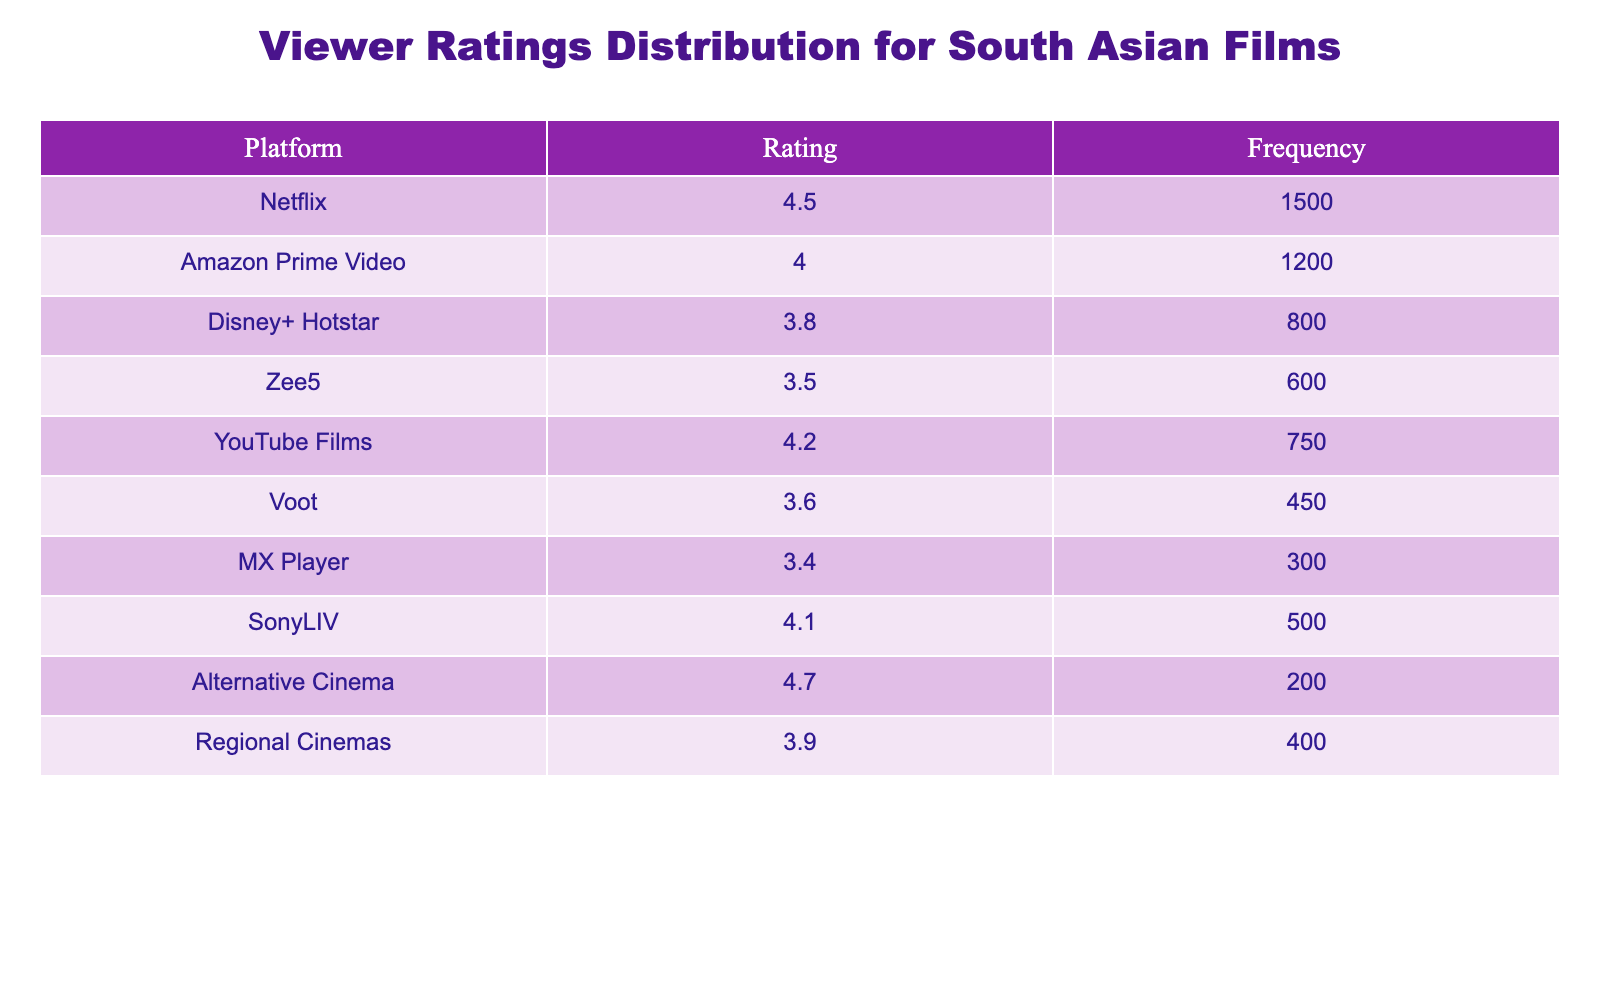What platform has the highest viewer rating? The platform with the highest viewer rating is Alternative Cinema, which has a rating of 4.7.
Answer: Alternative Cinema How many films are rated 4.0 or higher? The platforms with ratings of 4.0 or higher are Netflix (4.5), Amazon Prime Video (4.0), YouTube Films (4.2), SonyLIV (4.1), and Alternative Cinema (4.7). There are a total of 5 platforms in this category.
Answer: 5 What is the total frequency of films with ratings below 4.0? The platforms with ratings below 4.0 are Disney+ Hotstar (3.8), Zee5 (3.5), Voot (3.6), MX Player (3.4), and Regional Cinemas (3.9). The frequencies for these platforms are 800, 600, 450, 300, and 400 respectively. The total frequency is 800 + 600 + 450 + 300 + 400 = 2550.
Answer: 2550 Is the average viewer rating across all platforms greater than 3.5? First, calculate the total ratings and the total number of platforms. The total ratings are (4.5 + 4.0 + 3.8 + 3.5 + 4.2 + 3.6 + 3.4 + 4.1 + 4.7 + 3.9) = 41.7. There are 10 platforms, so the average rating is 41.7 / 10 = 4.17, which is greater than 3.5.
Answer: Yes Which platform has the lowest frequency rating? The platform with the lowest frequency is MX Player, with a frequency of 300.
Answer: MX Player 